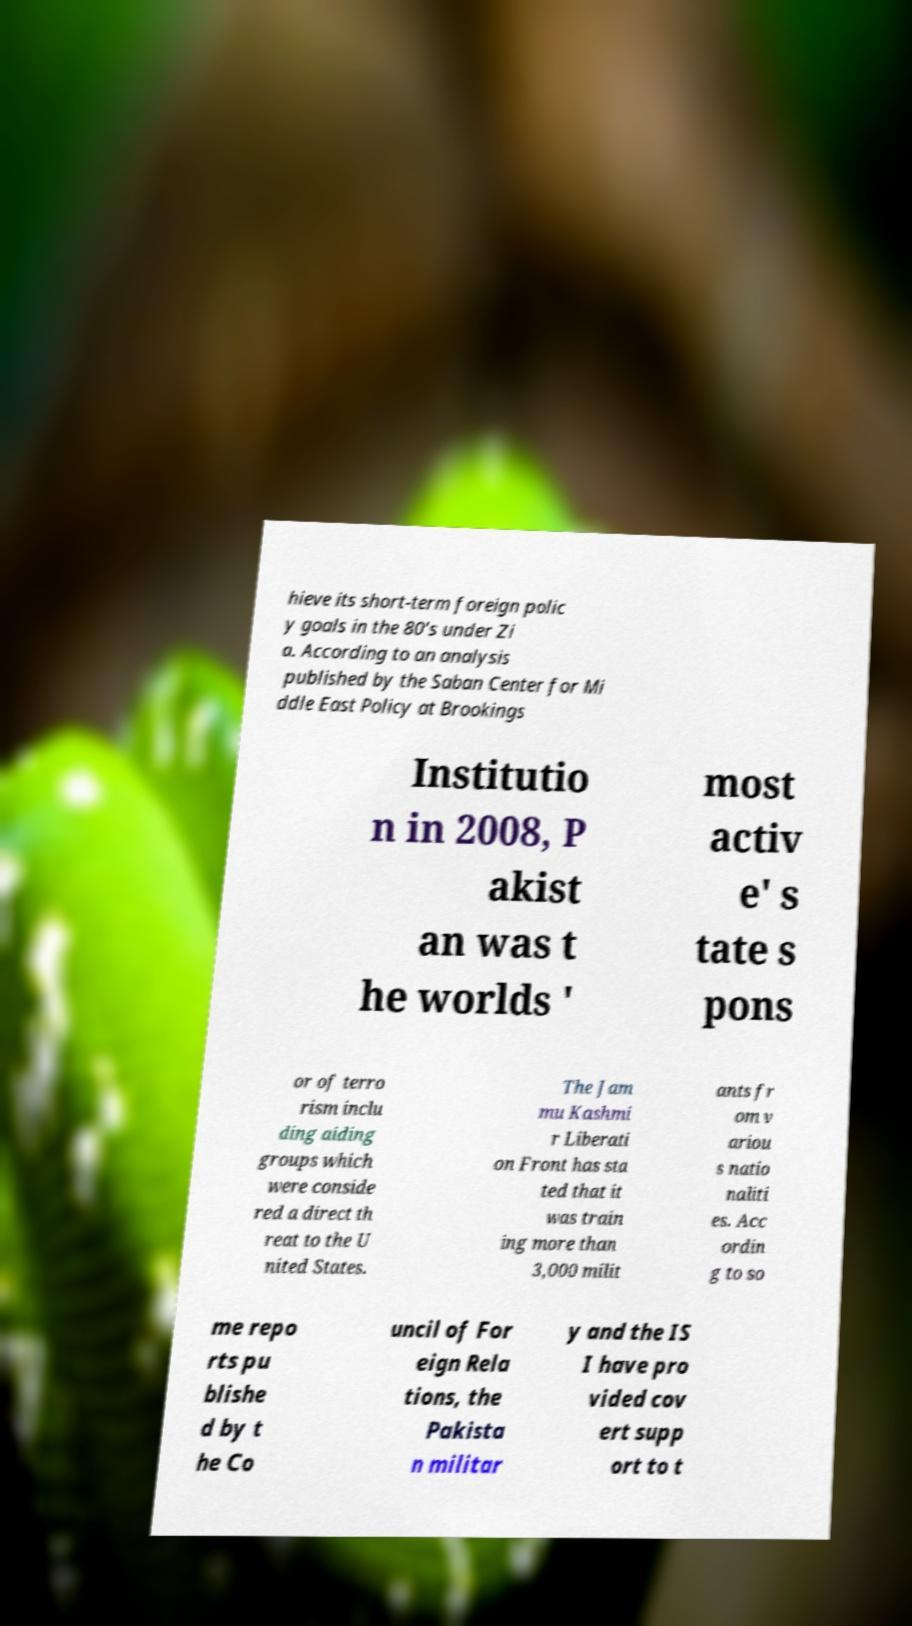For documentation purposes, I need the text within this image transcribed. Could you provide that? hieve its short-term foreign polic y goals in the 80’s under Zi a. According to an analysis published by the Saban Center for Mi ddle East Policy at Brookings Institutio n in 2008, P akist an was t he worlds ' most activ e' s tate s pons or of terro rism inclu ding aiding groups which were conside red a direct th reat to the U nited States. The Jam mu Kashmi r Liberati on Front has sta ted that it was train ing more than 3,000 milit ants fr om v ariou s natio naliti es. Acc ordin g to so me repo rts pu blishe d by t he Co uncil of For eign Rela tions, the Pakista n militar y and the IS I have pro vided cov ert supp ort to t 